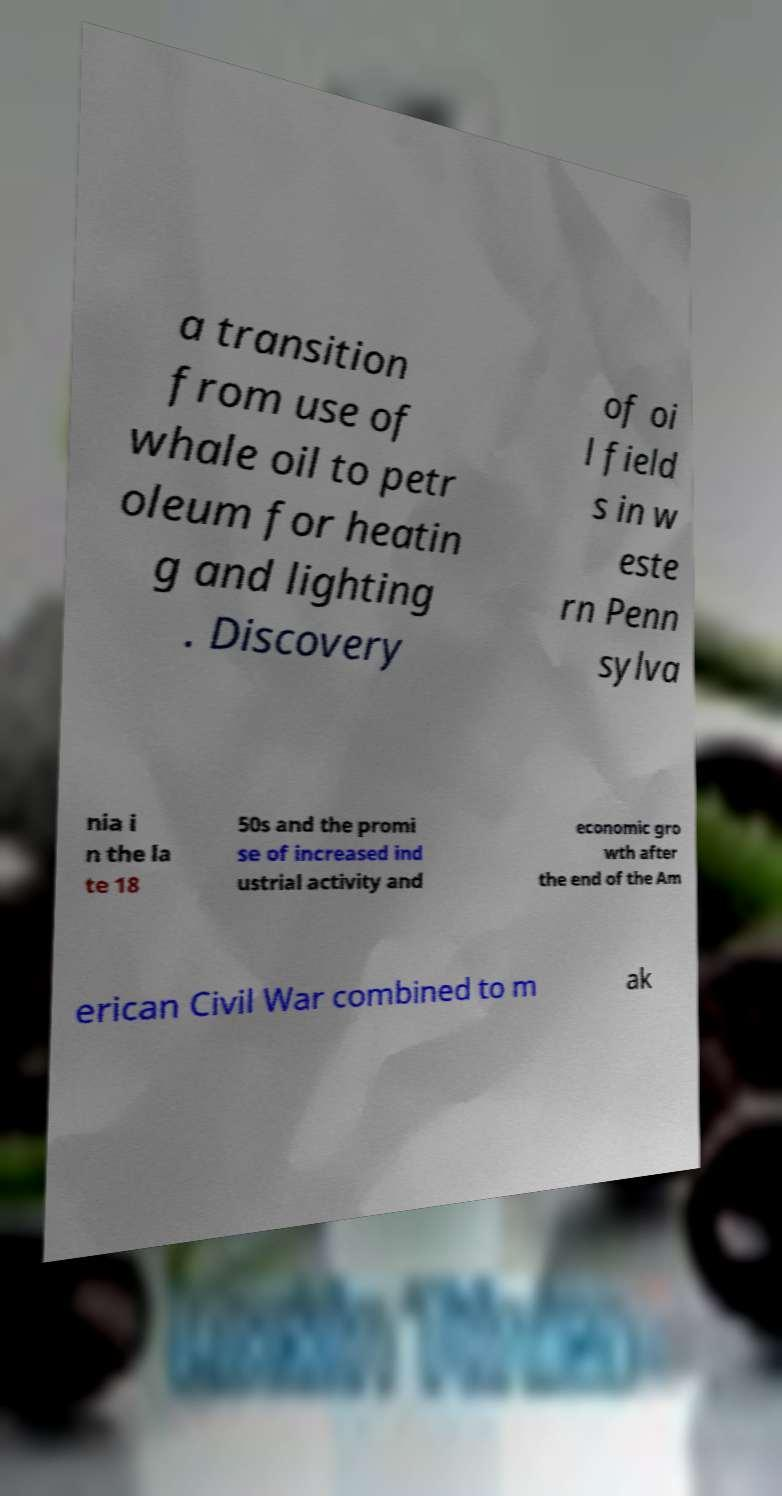What messages or text are displayed in this image? I need them in a readable, typed format. a transition from use of whale oil to petr oleum for heatin g and lighting . Discovery of oi l field s in w este rn Penn sylva nia i n the la te 18 50s and the promi se of increased ind ustrial activity and economic gro wth after the end of the Am erican Civil War combined to m ak 